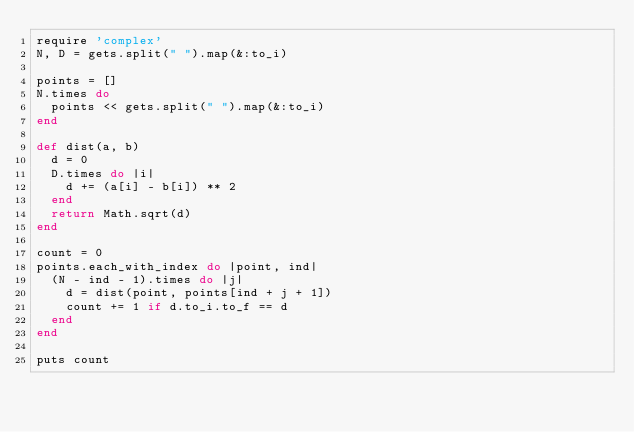<code> <loc_0><loc_0><loc_500><loc_500><_Ruby_>require 'complex'
N, D = gets.split(" ").map(&:to_i)

points = []
N.times do
  points << gets.split(" ").map(&:to_i)
end

def dist(a, b)
  d = 0
  D.times do |i|
    d += (a[i] - b[i]) ** 2
  end
  return Math.sqrt(d)
end

count = 0
points.each_with_index do |point, ind|
  (N - ind - 1).times do |j|
    d = dist(point, points[ind + j + 1])
    count += 1 if d.to_i.to_f == d
  end
end

puts count</code> 